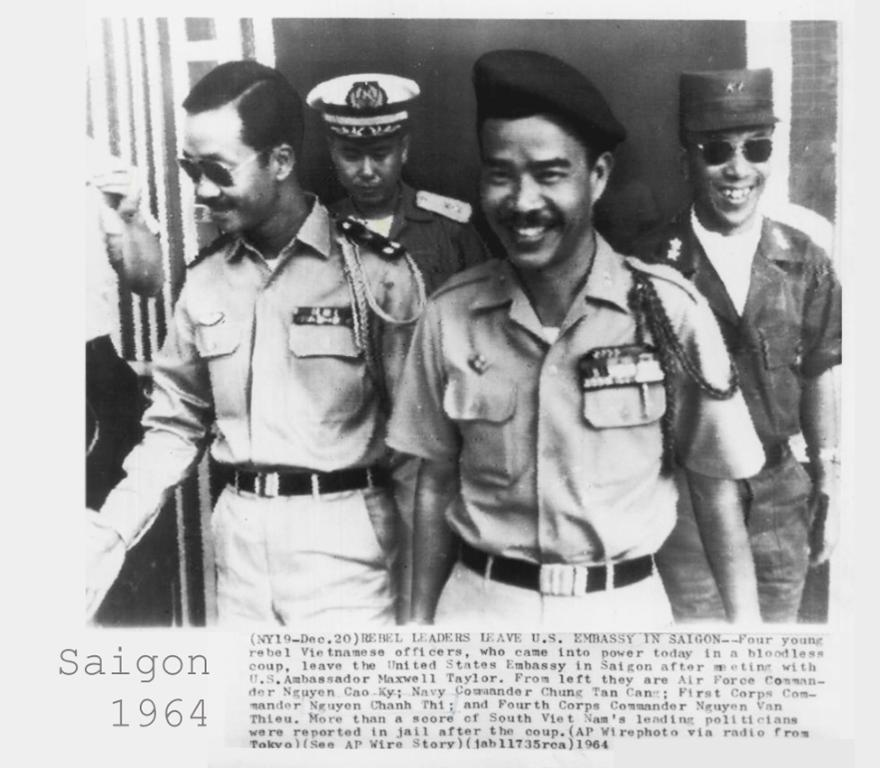What is the main subject of the paper in the image? The paper contains a photograph of four persons. Can you describe the expressions of the persons in the photograph? Three of the persons in the photograph are smiling. Is there any text on the paper? Yes, there is text at the bottom of the paper. How many feet can be seen in the image? There are no feet visible in the image; it features a paper with a photograph and text. What type of dinner is being served in the image? There is no dinner present in the image; it features a paper with a photograph and text. 